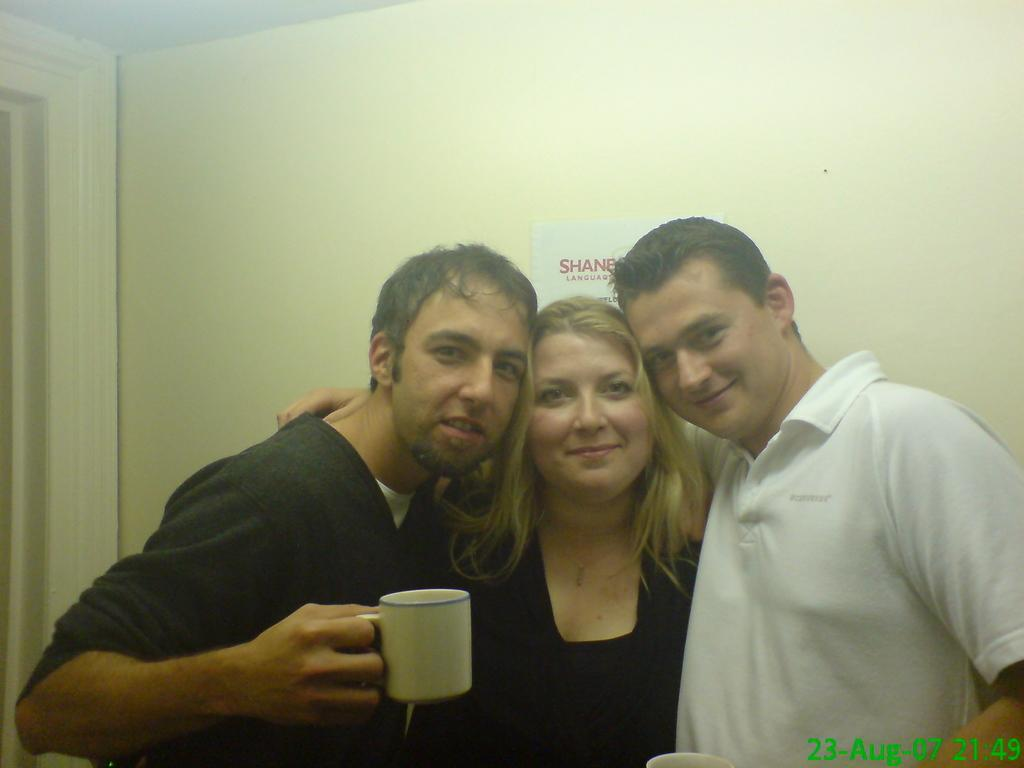How many people are in the image? There are three persons in the image. What is one of the persons holding? One of the persons is holding a cup. What can be seen in the background of the image? There is a wall in the background of the image. What happens when the cup bursts in the image? There is no indication in the image that the cup bursts, so it cannot be determined from the picture. 